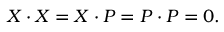Convert formula to latex. <formula><loc_0><loc_0><loc_500><loc_500>X \cdot X = X \cdot P = P \cdot P = 0 .</formula> 